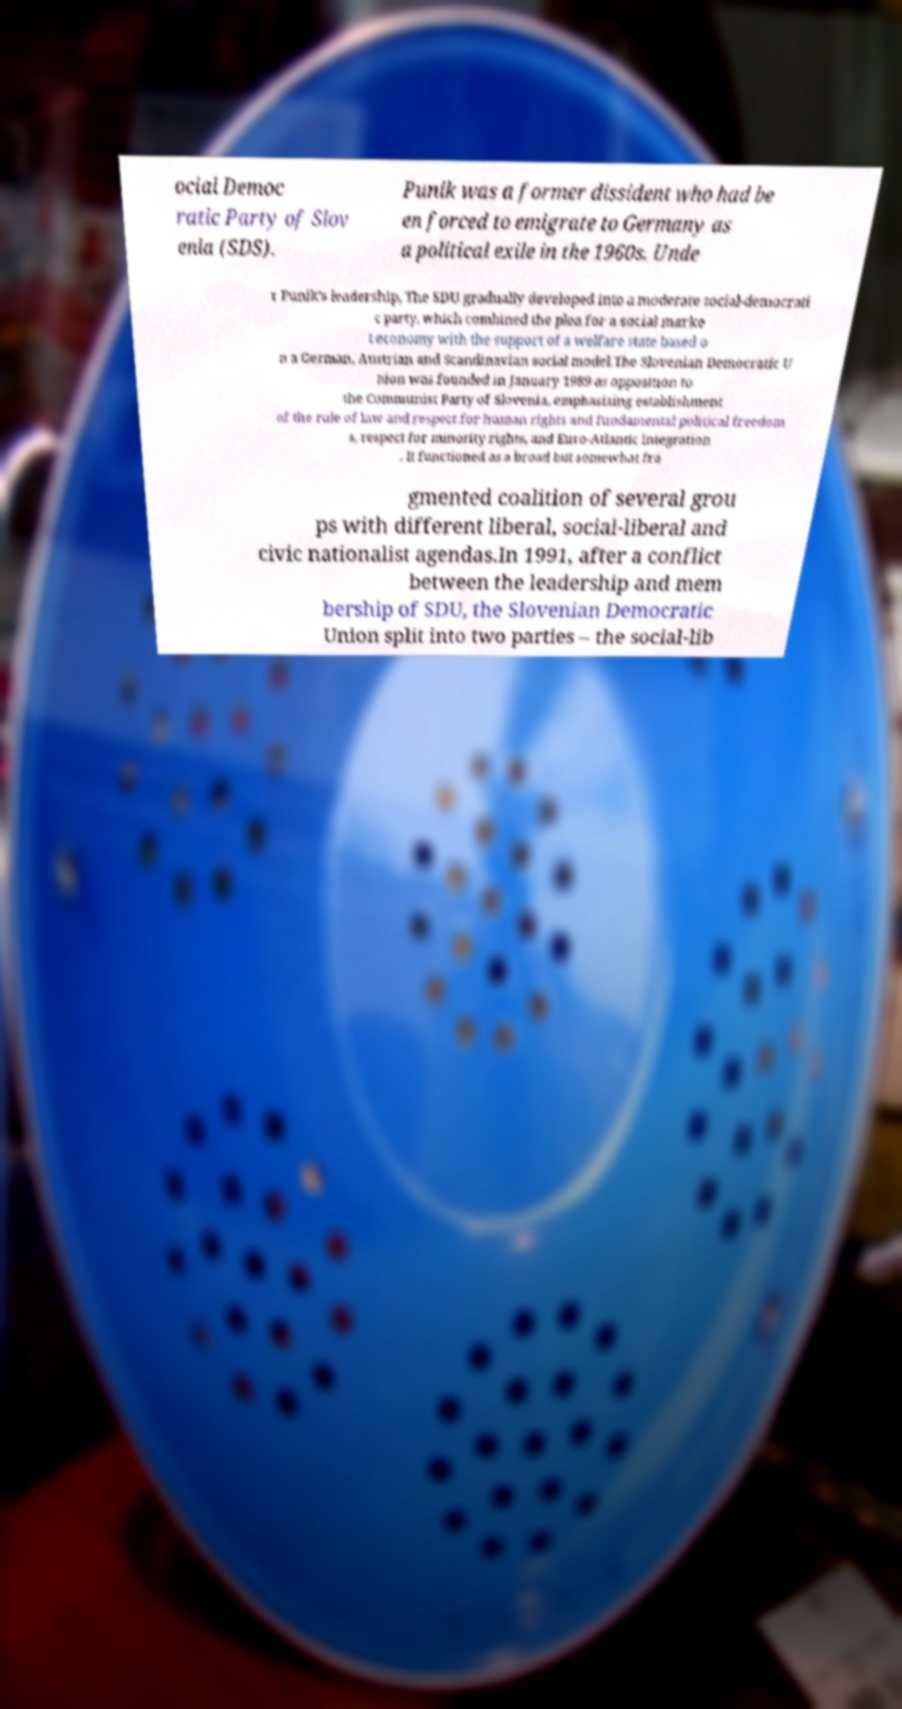Please read and relay the text visible in this image. What does it say? ocial Democ ratic Party of Slov enia (SDS). Punik was a former dissident who had be en forced to emigrate to Germany as a political exile in the 1960s. Unde r Punik's leadership, The SDU gradually developed into a moderate social-democrati c party, which combined the plea for a social marke t economy with the support of a welfare state based o n a German, Austrian and Scandinavian social model.The Slovenian Democratic U nion was founded in January 1989 as opposition to the Communist Party of Slovenia, emphasizing establishment of the rule of law and respect for human rights and fundamental political freedom s, respect for minority rights, and Euro-Atlantic integration . It functioned as a broad but somewhat fra gmented coalition of several grou ps with different liberal, social-liberal and civic nationalist agendas.In 1991, after a conflict between the leadership and mem bership of SDU, the Slovenian Democratic Union split into two parties – the social-lib 